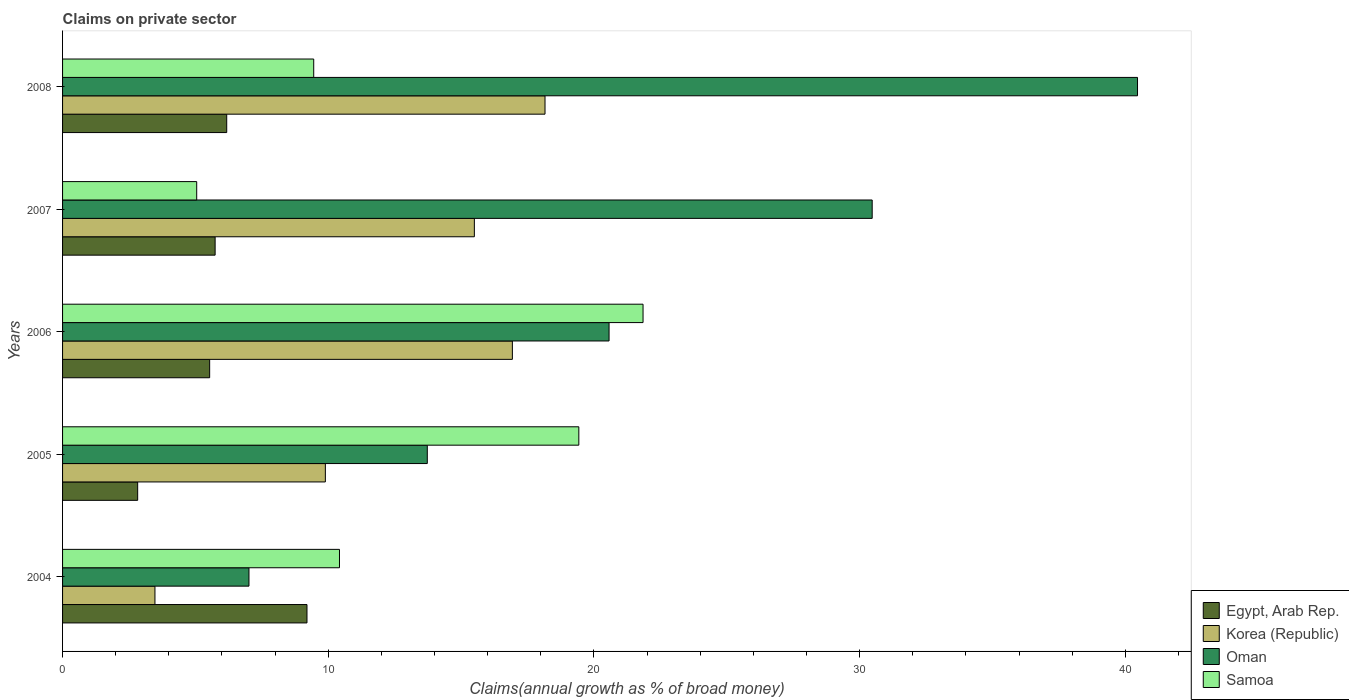How many groups of bars are there?
Give a very brief answer. 5. Are the number of bars per tick equal to the number of legend labels?
Give a very brief answer. Yes. How many bars are there on the 3rd tick from the bottom?
Give a very brief answer. 4. What is the label of the 3rd group of bars from the top?
Ensure brevity in your answer.  2006. In how many cases, is the number of bars for a given year not equal to the number of legend labels?
Provide a short and direct response. 0. What is the percentage of broad money claimed on private sector in Samoa in 2007?
Provide a succinct answer. 5.05. Across all years, what is the maximum percentage of broad money claimed on private sector in Samoa?
Give a very brief answer. 21.85. Across all years, what is the minimum percentage of broad money claimed on private sector in Oman?
Ensure brevity in your answer.  7.02. What is the total percentage of broad money claimed on private sector in Samoa in the graph?
Provide a succinct answer. 66.2. What is the difference between the percentage of broad money claimed on private sector in Korea (Republic) in 2005 and that in 2008?
Offer a very short reply. -8.27. What is the difference between the percentage of broad money claimed on private sector in Samoa in 2005 and the percentage of broad money claimed on private sector in Korea (Republic) in 2007?
Make the answer very short. 3.93. What is the average percentage of broad money claimed on private sector in Korea (Republic) per year?
Keep it short and to the point. 12.79. In the year 2007, what is the difference between the percentage of broad money claimed on private sector in Samoa and percentage of broad money claimed on private sector in Korea (Republic)?
Provide a short and direct response. -10.45. What is the ratio of the percentage of broad money claimed on private sector in Samoa in 2004 to that in 2007?
Give a very brief answer. 2.06. Is the percentage of broad money claimed on private sector in Korea (Republic) in 2005 less than that in 2006?
Provide a succinct answer. Yes. Is the difference between the percentage of broad money claimed on private sector in Samoa in 2005 and 2006 greater than the difference between the percentage of broad money claimed on private sector in Korea (Republic) in 2005 and 2006?
Your answer should be compact. Yes. What is the difference between the highest and the second highest percentage of broad money claimed on private sector in Korea (Republic)?
Your answer should be very brief. 1.23. What is the difference between the highest and the lowest percentage of broad money claimed on private sector in Samoa?
Keep it short and to the point. 16.8. In how many years, is the percentage of broad money claimed on private sector in Egypt, Arab Rep. greater than the average percentage of broad money claimed on private sector in Egypt, Arab Rep. taken over all years?
Give a very brief answer. 2. Is the sum of the percentage of broad money claimed on private sector in Egypt, Arab Rep. in 2005 and 2008 greater than the maximum percentage of broad money claimed on private sector in Oman across all years?
Provide a short and direct response. No. Is it the case that in every year, the sum of the percentage of broad money claimed on private sector in Egypt, Arab Rep. and percentage of broad money claimed on private sector in Samoa is greater than the sum of percentage of broad money claimed on private sector in Oman and percentage of broad money claimed on private sector in Korea (Republic)?
Make the answer very short. No. What does the 4th bar from the bottom in 2005 represents?
Give a very brief answer. Samoa. Is it the case that in every year, the sum of the percentage of broad money claimed on private sector in Korea (Republic) and percentage of broad money claimed on private sector in Egypt, Arab Rep. is greater than the percentage of broad money claimed on private sector in Oman?
Give a very brief answer. No. How many bars are there?
Your answer should be compact. 20. How many years are there in the graph?
Make the answer very short. 5. Does the graph contain any zero values?
Ensure brevity in your answer.  No. Where does the legend appear in the graph?
Your response must be concise. Bottom right. What is the title of the graph?
Offer a very short reply. Claims on private sector. What is the label or title of the X-axis?
Offer a very short reply. Claims(annual growth as % of broad money). What is the label or title of the Y-axis?
Provide a succinct answer. Years. What is the Claims(annual growth as % of broad money) of Egypt, Arab Rep. in 2004?
Ensure brevity in your answer.  9.2. What is the Claims(annual growth as % of broad money) of Korea (Republic) in 2004?
Your answer should be compact. 3.48. What is the Claims(annual growth as % of broad money) in Oman in 2004?
Keep it short and to the point. 7.02. What is the Claims(annual growth as % of broad money) in Samoa in 2004?
Offer a terse response. 10.42. What is the Claims(annual growth as % of broad money) of Egypt, Arab Rep. in 2005?
Ensure brevity in your answer.  2.83. What is the Claims(annual growth as % of broad money) in Korea (Republic) in 2005?
Offer a very short reply. 9.89. What is the Claims(annual growth as % of broad money) in Oman in 2005?
Offer a terse response. 13.73. What is the Claims(annual growth as % of broad money) in Samoa in 2005?
Give a very brief answer. 19.43. What is the Claims(annual growth as % of broad money) of Egypt, Arab Rep. in 2006?
Make the answer very short. 5.54. What is the Claims(annual growth as % of broad money) in Korea (Republic) in 2006?
Make the answer very short. 16.93. What is the Claims(annual growth as % of broad money) of Oman in 2006?
Your answer should be compact. 20.57. What is the Claims(annual growth as % of broad money) of Samoa in 2006?
Provide a succinct answer. 21.85. What is the Claims(annual growth as % of broad money) in Egypt, Arab Rep. in 2007?
Your answer should be very brief. 5.74. What is the Claims(annual growth as % of broad money) in Korea (Republic) in 2007?
Provide a short and direct response. 15.5. What is the Claims(annual growth as % of broad money) in Oman in 2007?
Your answer should be very brief. 30.47. What is the Claims(annual growth as % of broad money) in Samoa in 2007?
Offer a very short reply. 5.05. What is the Claims(annual growth as % of broad money) in Egypt, Arab Rep. in 2008?
Ensure brevity in your answer.  6.18. What is the Claims(annual growth as % of broad money) in Korea (Republic) in 2008?
Your answer should be very brief. 18.16. What is the Claims(annual growth as % of broad money) of Oman in 2008?
Your answer should be very brief. 40.46. What is the Claims(annual growth as % of broad money) in Samoa in 2008?
Offer a very short reply. 9.45. Across all years, what is the maximum Claims(annual growth as % of broad money) of Egypt, Arab Rep.?
Give a very brief answer. 9.2. Across all years, what is the maximum Claims(annual growth as % of broad money) of Korea (Republic)?
Your answer should be very brief. 18.16. Across all years, what is the maximum Claims(annual growth as % of broad money) of Oman?
Provide a short and direct response. 40.46. Across all years, what is the maximum Claims(annual growth as % of broad money) of Samoa?
Offer a terse response. 21.85. Across all years, what is the minimum Claims(annual growth as % of broad money) in Egypt, Arab Rep.?
Offer a terse response. 2.83. Across all years, what is the minimum Claims(annual growth as % of broad money) of Korea (Republic)?
Give a very brief answer. 3.48. Across all years, what is the minimum Claims(annual growth as % of broad money) of Oman?
Keep it short and to the point. 7.02. Across all years, what is the minimum Claims(annual growth as % of broad money) of Samoa?
Offer a very short reply. 5.05. What is the total Claims(annual growth as % of broad money) of Egypt, Arab Rep. in the graph?
Provide a succinct answer. 29.48. What is the total Claims(annual growth as % of broad money) of Korea (Republic) in the graph?
Provide a short and direct response. 63.95. What is the total Claims(annual growth as % of broad money) in Oman in the graph?
Your response must be concise. 112.24. What is the total Claims(annual growth as % of broad money) in Samoa in the graph?
Ensure brevity in your answer.  66.2. What is the difference between the Claims(annual growth as % of broad money) of Egypt, Arab Rep. in 2004 and that in 2005?
Your answer should be compact. 6.37. What is the difference between the Claims(annual growth as % of broad money) of Korea (Republic) in 2004 and that in 2005?
Ensure brevity in your answer.  -6.41. What is the difference between the Claims(annual growth as % of broad money) of Oman in 2004 and that in 2005?
Give a very brief answer. -6.71. What is the difference between the Claims(annual growth as % of broad money) in Samoa in 2004 and that in 2005?
Keep it short and to the point. -9.01. What is the difference between the Claims(annual growth as % of broad money) in Egypt, Arab Rep. in 2004 and that in 2006?
Make the answer very short. 3.66. What is the difference between the Claims(annual growth as % of broad money) in Korea (Republic) in 2004 and that in 2006?
Your answer should be very brief. -13.45. What is the difference between the Claims(annual growth as % of broad money) of Oman in 2004 and that in 2006?
Your answer should be compact. -13.55. What is the difference between the Claims(annual growth as % of broad money) in Samoa in 2004 and that in 2006?
Ensure brevity in your answer.  -11.43. What is the difference between the Claims(annual growth as % of broad money) of Egypt, Arab Rep. in 2004 and that in 2007?
Give a very brief answer. 3.46. What is the difference between the Claims(annual growth as % of broad money) of Korea (Republic) in 2004 and that in 2007?
Provide a short and direct response. -12.02. What is the difference between the Claims(annual growth as % of broad money) in Oman in 2004 and that in 2007?
Provide a short and direct response. -23.46. What is the difference between the Claims(annual growth as % of broad money) of Samoa in 2004 and that in 2007?
Your response must be concise. 5.37. What is the difference between the Claims(annual growth as % of broad money) of Egypt, Arab Rep. in 2004 and that in 2008?
Your answer should be compact. 3.02. What is the difference between the Claims(annual growth as % of broad money) in Korea (Republic) in 2004 and that in 2008?
Offer a very short reply. -14.68. What is the difference between the Claims(annual growth as % of broad money) in Oman in 2004 and that in 2008?
Offer a very short reply. -33.44. What is the difference between the Claims(annual growth as % of broad money) of Egypt, Arab Rep. in 2005 and that in 2006?
Offer a very short reply. -2.71. What is the difference between the Claims(annual growth as % of broad money) in Korea (Republic) in 2005 and that in 2006?
Keep it short and to the point. -7.04. What is the difference between the Claims(annual growth as % of broad money) of Oman in 2005 and that in 2006?
Offer a very short reply. -6.84. What is the difference between the Claims(annual growth as % of broad money) of Samoa in 2005 and that in 2006?
Make the answer very short. -2.42. What is the difference between the Claims(annual growth as % of broad money) in Egypt, Arab Rep. in 2005 and that in 2007?
Offer a very short reply. -2.92. What is the difference between the Claims(annual growth as % of broad money) of Korea (Republic) in 2005 and that in 2007?
Your answer should be compact. -5.61. What is the difference between the Claims(annual growth as % of broad money) of Oman in 2005 and that in 2007?
Ensure brevity in your answer.  -16.74. What is the difference between the Claims(annual growth as % of broad money) of Samoa in 2005 and that in 2007?
Keep it short and to the point. 14.38. What is the difference between the Claims(annual growth as % of broad money) in Egypt, Arab Rep. in 2005 and that in 2008?
Make the answer very short. -3.35. What is the difference between the Claims(annual growth as % of broad money) in Korea (Republic) in 2005 and that in 2008?
Keep it short and to the point. -8.27. What is the difference between the Claims(annual growth as % of broad money) of Oman in 2005 and that in 2008?
Keep it short and to the point. -26.73. What is the difference between the Claims(annual growth as % of broad money) in Samoa in 2005 and that in 2008?
Keep it short and to the point. 9.98. What is the difference between the Claims(annual growth as % of broad money) in Egypt, Arab Rep. in 2006 and that in 2007?
Make the answer very short. -0.21. What is the difference between the Claims(annual growth as % of broad money) of Korea (Republic) in 2006 and that in 2007?
Your response must be concise. 1.43. What is the difference between the Claims(annual growth as % of broad money) in Oman in 2006 and that in 2007?
Ensure brevity in your answer.  -9.9. What is the difference between the Claims(annual growth as % of broad money) in Samoa in 2006 and that in 2007?
Give a very brief answer. 16.8. What is the difference between the Claims(annual growth as % of broad money) in Egypt, Arab Rep. in 2006 and that in 2008?
Offer a terse response. -0.64. What is the difference between the Claims(annual growth as % of broad money) in Korea (Republic) in 2006 and that in 2008?
Offer a very short reply. -1.23. What is the difference between the Claims(annual growth as % of broad money) of Oman in 2006 and that in 2008?
Your response must be concise. -19.89. What is the difference between the Claims(annual growth as % of broad money) in Samoa in 2006 and that in 2008?
Ensure brevity in your answer.  12.4. What is the difference between the Claims(annual growth as % of broad money) of Egypt, Arab Rep. in 2007 and that in 2008?
Keep it short and to the point. -0.44. What is the difference between the Claims(annual growth as % of broad money) of Korea (Republic) in 2007 and that in 2008?
Make the answer very short. -2.66. What is the difference between the Claims(annual growth as % of broad money) of Oman in 2007 and that in 2008?
Provide a succinct answer. -9.99. What is the difference between the Claims(annual growth as % of broad money) in Samoa in 2007 and that in 2008?
Offer a very short reply. -4.4. What is the difference between the Claims(annual growth as % of broad money) of Egypt, Arab Rep. in 2004 and the Claims(annual growth as % of broad money) of Korea (Republic) in 2005?
Your answer should be compact. -0.69. What is the difference between the Claims(annual growth as % of broad money) of Egypt, Arab Rep. in 2004 and the Claims(annual growth as % of broad money) of Oman in 2005?
Give a very brief answer. -4.53. What is the difference between the Claims(annual growth as % of broad money) of Egypt, Arab Rep. in 2004 and the Claims(annual growth as % of broad money) of Samoa in 2005?
Make the answer very short. -10.23. What is the difference between the Claims(annual growth as % of broad money) in Korea (Republic) in 2004 and the Claims(annual growth as % of broad money) in Oman in 2005?
Provide a succinct answer. -10.25. What is the difference between the Claims(annual growth as % of broad money) of Korea (Republic) in 2004 and the Claims(annual growth as % of broad money) of Samoa in 2005?
Provide a short and direct response. -15.95. What is the difference between the Claims(annual growth as % of broad money) in Oman in 2004 and the Claims(annual growth as % of broad money) in Samoa in 2005?
Your answer should be very brief. -12.41. What is the difference between the Claims(annual growth as % of broad money) in Egypt, Arab Rep. in 2004 and the Claims(annual growth as % of broad money) in Korea (Republic) in 2006?
Offer a very short reply. -7.73. What is the difference between the Claims(annual growth as % of broad money) in Egypt, Arab Rep. in 2004 and the Claims(annual growth as % of broad money) in Oman in 2006?
Offer a terse response. -11.37. What is the difference between the Claims(annual growth as % of broad money) in Egypt, Arab Rep. in 2004 and the Claims(annual growth as % of broad money) in Samoa in 2006?
Provide a succinct answer. -12.65. What is the difference between the Claims(annual growth as % of broad money) of Korea (Republic) in 2004 and the Claims(annual growth as % of broad money) of Oman in 2006?
Offer a terse response. -17.09. What is the difference between the Claims(annual growth as % of broad money) in Korea (Republic) in 2004 and the Claims(annual growth as % of broad money) in Samoa in 2006?
Your answer should be compact. -18.37. What is the difference between the Claims(annual growth as % of broad money) in Oman in 2004 and the Claims(annual growth as % of broad money) in Samoa in 2006?
Your answer should be compact. -14.83. What is the difference between the Claims(annual growth as % of broad money) in Egypt, Arab Rep. in 2004 and the Claims(annual growth as % of broad money) in Korea (Republic) in 2007?
Offer a terse response. -6.3. What is the difference between the Claims(annual growth as % of broad money) of Egypt, Arab Rep. in 2004 and the Claims(annual growth as % of broad money) of Oman in 2007?
Offer a very short reply. -21.27. What is the difference between the Claims(annual growth as % of broad money) in Egypt, Arab Rep. in 2004 and the Claims(annual growth as % of broad money) in Samoa in 2007?
Your response must be concise. 4.15. What is the difference between the Claims(annual growth as % of broad money) in Korea (Republic) in 2004 and the Claims(annual growth as % of broad money) in Oman in 2007?
Your response must be concise. -26.99. What is the difference between the Claims(annual growth as % of broad money) of Korea (Republic) in 2004 and the Claims(annual growth as % of broad money) of Samoa in 2007?
Your answer should be very brief. -1.57. What is the difference between the Claims(annual growth as % of broad money) in Oman in 2004 and the Claims(annual growth as % of broad money) in Samoa in 2007?
Ensure brevity in your answer.  1.97. What is the difference between the Claims(annual growth as % of broad money) of Egypt, Arab Rep. in 2004 and the Claims(annual growth as % of broad money) of Korea (Republic) in 2008?
Make the answer very short. -8.96. What is the difference between the Claims(annual growth as % of broad money) of Egypt, Arab Rep. in 2004 and the Claims(annual growth as % of broad money) of Oman in 2008?
Provide a short and direct response. -31.26. What is the difference between the Claims(annual growth as % of broad money) in Egypt, Arab Rep. in 2004 and the Claims(annual growth as % of broad money) in Samoa in 2008?
Offer a terse response. -0.25. What is the difference between the Claims(annual growth as % of broad money) of Korea (Republic) in 2004 and the Claims(annual growth as % of broad money) of Oman in 2008?
Offer a very short reply. -36.98. What is the difference between the Claims(annual growth as % of broad money) of Korea (Republic) in 2004 and the Claims(annual growth as % of broad money) of Samoa in 2008?
Provide a succinct answer. -5.98. What is the difference between the Claims(annual growth as % of broad money) in Oman in 2004 and the Claims(annual growth as % of broad money) in Samoa in 2008?
Give a very brief answer. -2.44. What is the difference between the Claims(annual growth as % of broad money) of Egypt, Arab Rep. in 2005 and the Claims(annual growth as % of broad money) of Korea (Republic) in 2006?
Provide a succinct answer. -14.1. What is the difference between the Claims(annual growth as % of broad money) in Egypt, Arab Rep. in 2005 and the Claims(annual growth as % of broad money) in Oman in 2006?
Ensure brevity in your answer.  -17.74. What is the difference between the Claims(annual growth as % of broad money) in Egypt, Arab Rep. in 2005 and the Claims(annual growth as % of broad money) in Samoa in 2006?
Offer a very short reply. -19.02. What is the difference between the Claims(annual growth as % of broad money) in Korea (Republic) in 2005 and the Claims(annual growth as % of broad money) in Oman in 2006?
Your answer should be compact. -10.68. What is the difference between the Claims(annual growth as % of broad money) in Korea (Republic) in 2005 and the Claims(annual growth as % of broad money) in Samoa in 2006?
Your answer should be compact. -11.96. What is the difference between the Claims(annual growth as % of broad money) in Oman in 2005 and the Claims(annual growth as % of broad money) in Samoa in 2006?
Your answer should be very brief. -8.12. What is the difference between the Claims(annual growth as % of broad money) of Egypt, Arab Rep. in 2005 and the Claims(annual growth as % of broad money) of Korea (Republic) in 2007?
Your response must be concise. -12.67. What is the difference between the Claims(annual growth as % of broad money) of Egypt, Arab Rep. in 2005 and the Claims(annual growth as % of broad money) of Oman in 2007?
Make the answer very short. -27.65. What is the difference between the Claims(annual growth as % of broad money) of Egypt, Arab Rep. in 2005 and the Claims(annual growth as % of broad money) of Samoa in 2007?
Offer a very short reply. -2.22. What is the difference between the Claims(annual growth as % of broad money) in Korea (Republic) in 2005 and the Claims(annual growth as % of broad money) in Oman in 2007?
Your answer should be compact. -20.58. What is the difference between the Claims(annual growth as % of broad money) in Korea (Republic) in 2005 and the Claims(annual growth as % of broad money) in Samoa in 2007?
Offer a terse response. 4.84. What is the difference between the Claims(annual growth as % of broad money) in Oman in 2005 and the Claims(annual growth as % of broad money) in Samoa in 2007?
Provide a succinct answer. 8.68. What is the difference between the Claims(annual growth as % of broad money) in Egypt, Arab Rep. in 2005 and the Claims(annual growth as % of broad money) in Korea (Republic) in 2008?
Your answer should be compact. -15.33. What is the difference between the Claims(annual growth as % of broad money) in Egypt, Arab Rep. in 2005 and the Claims(annual growth as % of broad money) in Oman in 2008?
Offer a terse response. -37.63. What is the difference between the Claims(annual growth as % of broad money) of Egypt, Arab Rep. in 2005 and the Claims(annual growth as % of broad money) of Samoa in 2008?
Your answer should be very brief. -6.63. What is the difference between the Claims(annual growth as % of broad money) in Korea (Republic) in 2005 and the Claims(annual growth as % of broad money) in Oman in 2008?
Your response must be concise. -30.57. What is the difference between the Claims(annual growth as % of broad money) in Korea (Republic) in 2005 and the Claims(annual growth as % of broad money) in Samoa in 2008?
Your response must be concise. 0.44. What is the difference between the Claims(annual growth as % of broad money) in Oman in 2005 and the Claims(annual growth as % of broad money) in Samoa in 2008?
Provide a short and direct response. 4.28. What is the difference between the Claims(annual growth as % of broad money) in Egypt, Arab Rep. in 2006 and the Claims(annual growth as % of broad money) in Korea (Republic) in 2007?
Your answer should be very brief. -9.96. What is the difference between the Claims(annual growth as % of broad money) in Egypt, Arab Rep. in 2006 and the Claims(annual growth as % of broad money) in Oman in 2007?
Ensure brevity in your answer.  -24.94. What is the difference between the Claims(annual growth as % of broad money) in Egypt, Arab Rep. in 2006 and the Claims(annual growth as % of broad money) in Samoa in 2007?
Make the answer very short. 0.49. What is the difference between the Claims(annual growth as % of broad money) in Korea (Republic) in 2006 and the Claims(annual growth as % of broad money) in Oman in 2007?
Provide a short and direct response. -13.54. What is the difference between the Claims(annual growth as % of broad money) in Korea (Republic) in 2006 and the Claims(annual growth as % of broad money) in Samoa in 2007?
Offer a very short reply. 11.88. What is the difference between the Claims(annual growth as % of broad money) in Oman in 2006 and the Claims(annual growth as % of broad money) in Samoa in 2007?
Your response must be concise. 15.52. What is the difference between the Claims(annual growth as % of broad money) of Egypt, Arab Rep. in 2006 and the Claims(annual growth as % of broad money) of Korea (Republic) in 2008?
Your answer should be compact. -12.62. What is the difference between the Claims(annual growth as % of broad money) in Egypt, Arab Rep. in 2006 and the Claims(annual growth as % of broad money) in Oman in 2008?
Your answer should be compact. -34.92. What is the difference between the Claims(annual growth as % of broad money) of Egypt, Arab Rep. in 2006 and the Claims(annual growth as % of broad money) of Samoa in 2008?
Offer a terse response. -3.92. What is the difference between the Claims(annual growth as % of broad money) of Korea (Republic) in 2006 and the Claims(annual growth as % of broad money) of Oman in 2008?
Make the answer very short. -23.53. What is the difference between the Claims(annual growth as % of broad money) of Korea (Republic) in 2006 and the Claims(annual growth as % of broad money) of Samoa in 2008?
Offer a very short reply. 7.48. What is the difference between the Claims(annual growth as % of broad money) of Oman in 2006 and the Claims(annual growth as % of broad money) of Samoa in 2008?
Ensure brevity in your answer.  11.12. What is the difference between the Claims(annual growth as % of broad money) of Egypt, Arab Rep. in 2007 and the Claims(annual growth as % of broad money) of Korea (Republic) in 2008?
Make the answer very short. -12.42. What is the difference between the Claims(annual growth as % of broad money) in Egypt, Arab Rep. in 2007 and the Claims(annual growth as % of broad money) in Oman in 2008?
Provide a short and direct response. -34.72. What is the difference between the Claims(annual growth as % of broad money) in Egypt, Arab Rep. in 2007 and the Claims(annual growth as % of broad money) in Samoa in 2008?
Provide a short and direct response. -3.71. What is the difference between the Claims(annual growth as % of broad money) of Korea (Republic) in 2007 and the Claims(annual growth as % of broad money) of Oman in 2008?
Your answer should be compact. -24.96. What is the difference between the Claims(annual growth as % of broad money) in Korea (Republic) in 2007 and the Claims(annual growth as % of broad money) in Samoa in 2008?
Your answer should be compact. 6.05. What is the difference between the Claims(annual growth as % of broad money) in Oman in 2007 and the Claims(annual growth as % of broad money) in Samoa in 2008?
Your answer should be very brief. 21.02. What is the average Claims(annual growth as % of broad money) in Egypt, Arab Rep. per year?
Your response must be concise. 5.9. What is the average Claims(annual growth as % of broad money) in Korea (Republic) per year?
Ensure brevity in your answer.  12.79. What is the average Claims(annual growth as % of broad money) of Oman per year?
Offer a very short reply. 22.45. What is the average Claims(annual growth as % of broad money) of Samoa per year?
Ensure brevity in your answer.  13.24. In the year 2004, what is the difference between the Claims(annual growth as % of broad money) of Egypt, Arab Rep. and Claims(annual growth as % of broad money) of Korea (Republic)?
Give a very brief answer. 5.72. In the year 2004, what is the difference between the Claims(annual growth as % of broad money) in Egypt, Arab Rep. and Claims(annual growth as % of broad money) in Oman?
Offer a very short reply. 2.18. In the year 2004, what is the difference between the Claims(annual growth as % of broad money) in Egypt, Arab Rep. and Claims(annual growth as % of broad money) in Samoa?
Give a very brief answer. -1.22. In the year 2004, what is the difference between the Claims(annual growth as % of broad money) in Korea (Republic) and Claims(annual growth as % of broad money) in Oman?
Offer a terse response. -3.54. In the year 2004, what is the difference between the Claims(annual growth as % of broad money) of Korea (Republic) and Claims(annual growth as % of broad money) of Samoa?
Your answer should be compact. -6.95. In the year 2004, what is the difference between the Claims(annual growth as % of broad money) of Oman and Claims(annual growth as % of broad money) of Samoa?
Offer a terse response. -3.41. In the year 2005, what is the difference between the Claims(annual growth as % of broad money) in Egypt, Arab Rep. and Claims(annual growth as % of broad money) in Korea (Republic)?
Provide a short and direct response. -7.06. In the year 2005, what is the difference between the Claims(annual growth as % of broad money) of Egypt, Arab Rep. and Claims(annual growth as % of broad money) of Oman?
Your response must be concise. -10.9. In the year 2005, what is the difference between the Claims(annual growth as % of broad money) in Egypt, Arab Rep. and Claims(annual growth as % of broad money) in Samoa?
Your response must be concise. -16.6. In the year 2005, what is the difference between the Claims(annual growth as % of broad money) in Korea (Republic) and Claims(annual growth as % of broad money) in Oman?
Your answer should be compact. -3.84. In the year 2005, what is the difference between the Claims(annual growth as % of broad money) in Korea (Republic) and Claims(annual growth as % of broad money) in Samoa?
Provide a short and direct response. -9.54. In the year 2005, what is the difference between the Claims(annual growth as % of broad money) of Oman and Claims(annual growth as % of broad money) of Samoa?
Ensure brevity in your answer.  -5.7. In the year 2006, what is the difference between the Claims(annual growth as % of broad money) in Egypt, Arab Rep. and Claims(annual growth as % of broad money) in Korea (Republic)?
Give a very brief answer. -11.39. In the year 2006, what is the difference between the Claims(annual growth as % of broad money) in Egypt, Arab Rep. and Claims(annual growth as % of broad money) in Oman?
Provide a short and direct response. -15.03. In the year 2006, what is the difference between the Claims(annual growth as % of broad money) of Egypt, Arab Rep. and Claims(annual growth as % of broad money) of Samoa?
Provide a short and direct response. -16.31. In the year 2006, what is the difference between the Claims(annual growth as % of broad money) in Korea (Republic) and Claims(annual growth as % of broad money) in Oman?
Give a very brief answer. -3.64. In the year 2006, what is the difference between the Claims(annual growth as % of broad money) in Korea (Republic) and Claims(annual growth as % of broad money) in Samoa?
Make the answer very short. -4.92. In the year 2006, what is the difference between the Claims(annual growth as % of broad money) of Oman and Claims(annual growth as % of broad money) of Samoa?
Your answer should be very brief. -1.28. In the year 2007, what is the difference between the Claims(annual growth as % of broad money) of Egypt, Arab Rep. and Claims(annual growth as % of broad money) of Korea (Republic)?
Provide a short and direct response. -9.76. In the year 2007, what is the difference between the Claims(annual growth as % of broad money) in Egypt, Arab Rep. and Claims(annual growth as % of broad money) in Oman?
Make the answer very short. -24.73. In the year 2007, what is the difference between the Claims(annual growth as % of broad money) of Egypt, Arab Rep. and Claims(annual growth as % of broad money) of Samoa?
Provide a short and direct response. 0.69. In the year 2007, what is the difference between the Claims(annual growth as % of broad money) in Korea (Republic) and Claims(annual growth as % of broad money) in Oman?
Offer a very short reply. -14.97. In the year 2007, what is the difference between the Claims(annual growth as % of broad money) of Korea (Republic) and Claims(annual growth as % of broad money) of Samoa?
Offer a terse response. 10.45. In the year 2007, what is the difference between the Claims(annual growth as % of broad money) in Oman and Claims(annual growth as % of broad money) in Samoa?
Offer a terse response. 25.42. In the year 2008, what is the difference between the Claims(annual growth as % of broad money) in Egypt, Arab Rep. and Claims(annual growth as % of broad money) in Korea (Republic)?
Provide a short and direct response. -11.98. In the year 2008, what is the difference between the Claims(annual growth as % of broad money) of Egypt, Arab Rep. and Claims(annual growth as % of broad money) of Oman?
Provide a succinct answer. -34.28. In the year 2008, what is the difference between the Claims(annual growth as % of broad money) in Egypt, Arab Rep. and Claims(annual growth as % of broad money) in Samoa?
Provide a succinct answer. -3.27. In the year 2008, what is the difference between the Claims(annual growth as % of broad money) in Korea (Republic) and Claims(annual growth as % of broad money) in Oman?
Make the answer very short. -22.3. In the year 2008, what is the difference between the Claims(annual growth as % of broad money) of Korea (Republic) and Claims(annual growth as % of broad money) of Samoa?
Provide a succinct answer. 8.71. In the year 2008, what is the difference between the Claims(annual growth as % of broad money) of Oman and Claims(annual growth as % of broad money) of Samoa?
Your response must be concise. 31.01. What is the ratio of the Claims(annual growth as % of broad money) of Egypt, Arab Rep. in 2004 to that in 2005?
Your answer should be very brief. 3.25. What is the ratio of the Claims(annual growth as % of broad money) in Korea (Republic) in 2004 to that in 2005?
Your answer should be compact. 0.35. What is the ratio of the Claims(annual growth as % of broad money) in Oman in 2004 to that in 2005?
Your answer should be very brief. 0.51. What is the ratio of the Claims(annual growth as % of broad money) in Samoa in 2004 to that in 2005?
Provide a short and direct response. 0.54. What is the ratio of the Claims(annual growth as % of broad money) of Egypt, Arab Rep. in 2004 to that in 2006?
Your response must be concise. 1.66. What is the ratio of the Claims(annual growth as % of broad money) of Korea (Republic) in 2004 to that in 2006?
Your response must be concise. 0.21. What is the ratio of the Claims(annual growth as % of broad money) of Oman in 2004 to that in 2006?
Your answer should be very brief. 0.34. What is the ratio of the Claims(annual growth as % of broad money) in Samoa in 2004 to that in 2006?
Keep it short and to the point. 0.48. What is the ratio of the Claims(annual growth as % of broad money) in Egypt, Arab Rep. in 2004 to that in 2007?
Offer a very short reply. 1.6. What is the ratio of the Claims(annual growth as % of broad money) in Korea (Republic) in 2004 to that in 2007?
Offer a very short reply. 0.22. What is the ratio of the Claims(annual growth as % of broad money) of Oman in 2004 to that in 2007?
Your answer should be compact. 0.23. What is the ratio of the Claims(annual growth as % of broad money) of Samoa in 2004 to that in 2007?
Give a very brief answer. 2.06. What is the ratio of the Claims(annual growth as % of broad money) in Egypt, Arab Rep. in 2004 to that in 2008?
Ensure brevity in your answer.  1.49. What is the ratio of the Claims(annual growth as % of broad money) of Korea (Republic) in 2004 to that in 2008?
Keep it short and to the point. 0.19. What is the ratio of the Claims(annual growth as % of broad money) of Oman in 2004 to that in 2008?
Give a very brief answer. 0.17. What is the ratio of the Claims(annual growth as % of broad money) of Samoa in 2004 to that in 2008?
Provide a succinct answer. 1.1. What is the ratio of the Claims(annual growth as % of broad money) in Egypt, Arab Rep. in 2005 to that in 2006?
Keep it short and to the point. 0.51. What is the ratio of the Claims(annual growth as % of broad money) of Korea (Republic) in 2005 to that in 2006?
Your response must be concise. 0.58. What is the ratio of the Claims(annual growth as % of broad money) of Oman in 2005 to that in 2006?
Provide a succinct answer. 0.67. What is the ratio of the Claims(annual growth as % of broad money) in Samoa in 2005 to that in 2006?
Give a very brief answer. 0.89. What is the ratio of the Claims(annual growth as % of broad money) of Egypt, Arab Rep. in 2005 to that in 2007?
Your answer should be compact. 0.49. What is the ratio of the Claims(annual growth as % of broad money) in Korea (Republic) in 2005 to that in 2007?
Provide a short and direct response. 0.64. What is the ratio of the Claims(annual growth as % of broad money) of Oman in 2005 to that in 2007?
Your response must be concise. 0.45. What is the ratio of the Claims(annual growth as % of broad money) of Samoa in 2005 to that in 2007?
Offer a very short reply. 3.85. What is the ratio of the Claims(annual growth as % of broad money) in Egypt, Arab Rep. in 2005 to that in 2008?
Provide a succinct answer. 0.46. What is the ratio of the Claims(annual growth as % of broad money) in Korea (Republic) in 2005 to that in 2008?
Offer a terse response. 0.54. What is the ratio of the Claims(annual growth as % of broad money) of Oman in 2005 to that in 2008?
Ensure brevity in your answer.  0.34. What is the ratio of the Claims(annual growth as % of broad money) of Samoa in 2005 to that in 2008?
Make the answer very short. 2.06. What is the ratio of the Claims(annual growth as % of broad money) of Egypt, Arab Rep. in 2006 to that in 2007?
Offer a terse response. 0.96. What is the ratio of the Claims(annual growth as % of broad money) of Korea (Republic) in 2006 to that in 2007?
Your answer should be very brief. 1.09. What is the ratio of the Claims(annual growth as % of broad money) in Oman in 2006 to that in 2007?
Keep it short and to the point. 0.68. What is the ratio of the Claims(annual growth as % of broad money) of Samoa in 2006 to that in 2007?
Give a very brief answer. 4.33. What is the ratio of the Claims(annual growth as % of broad money) of Egypt, Arab Rep. in 2006 to that in 2008?
Ensure brevity in your answer.  0.9. What is the ratio of the Claims(annual growth as % of broad money) in Korea (Republic) in 2006 to that in 2008?
Ensure brevity in your answer.  0.93. What is the ratio of the Claims(annual growth as % of broad money) in Oman in 2006 to that in 2008?
Keep it short and to the point. 0.51. What is the ratio of the Claims(annual growth as % of broad money) in Samoa in 2006 to that in 2008?
Keep it short and to the point. 2.31. What is the ratio of the Claims(annual growth as % of broad money) of Egypt, Arab Rep. in 2007 to that in 2008?
Make the answer very short. 0.93. What is the ratio of the Claims(annual growth as % of broad money) in Korea (Republic) in 2007 to that in 2008?
Make the answer very short. 0.85. What is the ratio of the Claims(annual growth as % of broad money) in Oman in 2007 to that in 2008?
Your response must be concise. 0.75. What is the ratio of the Claims(annual growth as % of broad money) in Samoa in 2007 to that in 2008?
Your response must be concise. 0.53. What is the difference between the highest and the second highest Claims(annual growth as % of broad money) in Egypt, Arab Rep.?
Make the answer very short. 3.02. What is the difference between the highest and the second highest Claims(annual growth as % of broad money) in Korea (Republic)?
Ensure brevity in your answer.  1.23. What is the difference between the highest and the second highest Claims(annual growth as % of broad money) of Oman?
Keep it short and to the point. 9.99. What is the difference between the highest and the second highest Claims(annual growth as % of broad money) of Samoa?
Offer a very short reply. 2.42. What is the difference between the highest and the lowest Claims(annual growth as % of broad money) in Egypt, Arab Rep.?
Provide a short and direct response. 6.37. What is the difference between the highest and the lowest Claims(annual growth as % of broad money) in Korea (Republic)?
Your answer should be compact. 14.68. What is the difference between the highest and the lowest Claims(annual growth as % of broad money) of Oman?
Provide a succinct answer. 33.44. What is the difference between the highest and the lowest Claims(annual growth as % of broad money) of Samoa?
Your answer should be compact. 16.8. 